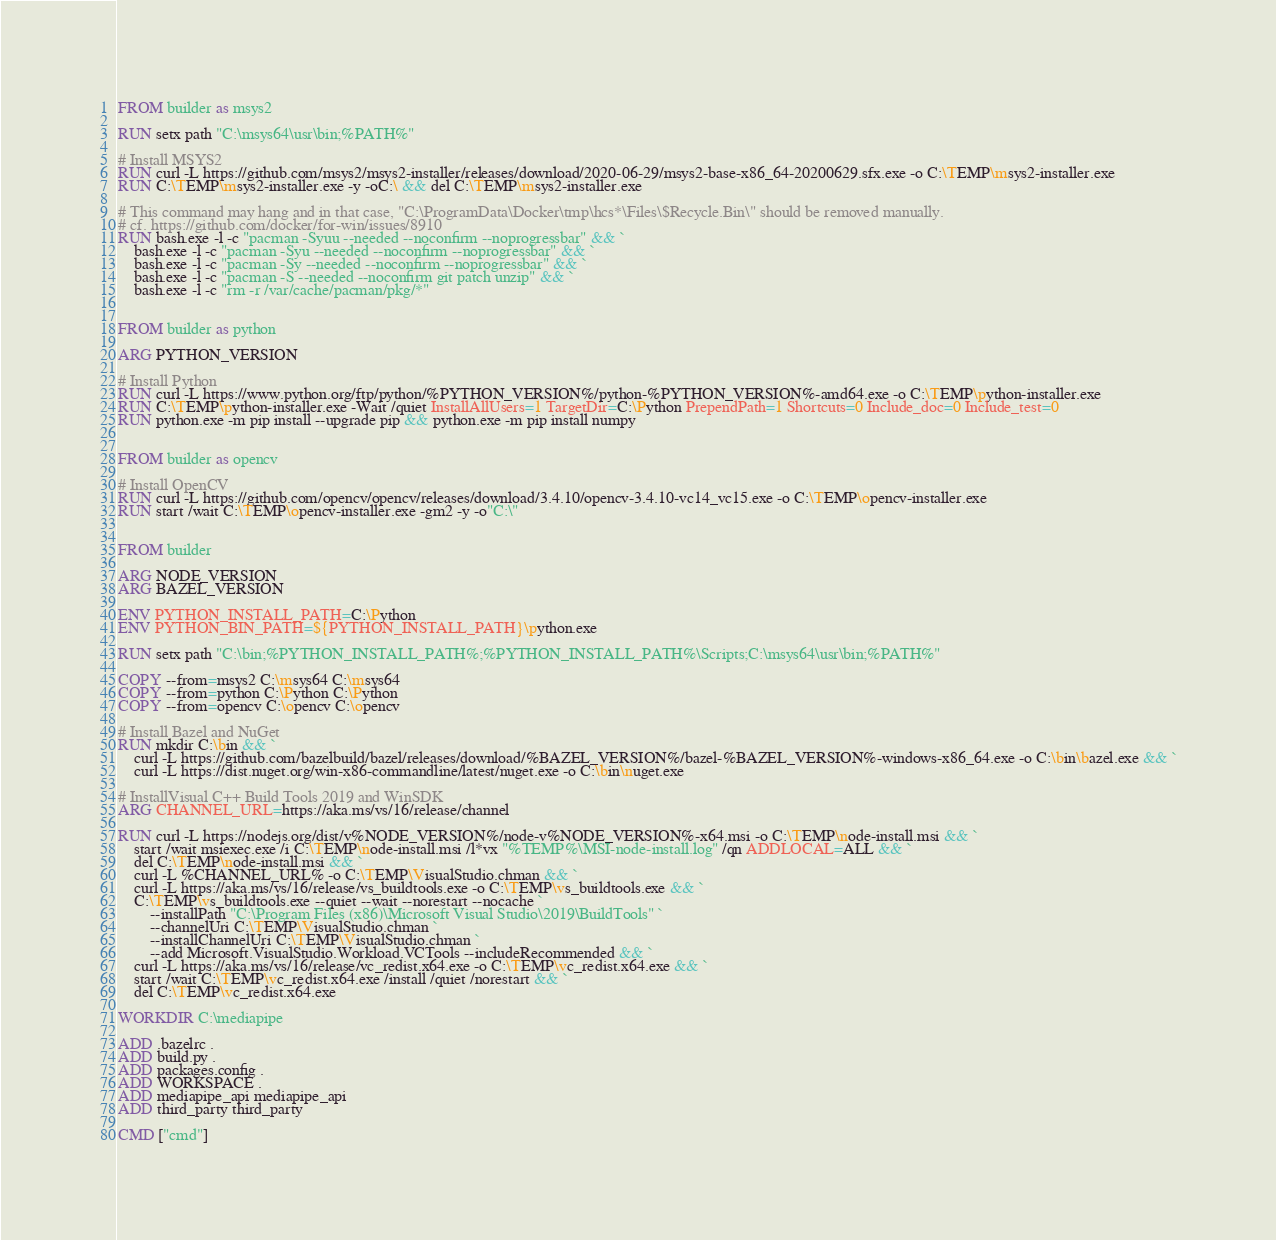Convert code to text. <code><loc_0><loc_0><loc_500><loc_500><_Dockerfile_>

FROM builder as msys2

RUN setx path "C:\msys64\usr\bin;%PATH%"

# Install MSYS2
RUN curl -L https://github.com/msys2/msys2-installer/releases/download/2020-06-29/msys2-base-x86_64-20200629.sfx.exe -o C:\TEMP\msys2-installer.exe
RUN C:\TEMP\msys2-installer.exe -y -oC:\ && del C:\TEMP\msys2-installer.exe

# This command may hang and in that case, "C:\ProgramData\Docker\tmp\hcs*\Files\$Recycle.Bin\" should be removed manually.
# cf. https://github.com/docker/for-win/issues/8910
RUN bash.exe -l -c "pacman -Syuu --needed --noconfirm --noprogressbar" && `
    bash.exe -l -c "pacman -Syu --needed --noconfirm --noprogressbar" && `
    bash.exe -l -c "pacman -Sy --needed --noconfirm --noprogressbar" && `
    bash.exe -l -c "pacman -S --needed --noconfirm git patch unzip" && `
    bash.exe -l -c "rm -r /var/cache/pacman/pkg/*"


FROM builder as python

ARG PYTHON_VERSION

# Install Python
RUN curl -L https://www.python.org/ftp/python/%PYTHON_VERSION%/python-%PYTHON_VERSION%-amd64.exe -o C:\TEMP\python-installer.exe
RUN C:\TEMP\python-installer.exe -Wait /quiet InstallAllUsers=1 TargetDir=C:\Python PrependPath=1 Shortcuts=0 Include_doc=0 Include_test=0
RUN python.exe -m pip install --upgrade pip && python.exe -m pip install numpy


FROM builder as opencv

# Install OpenCV
RUN curl -L https://github.com/opencv/opencv/releases/download/3.4.10/opencv-3.4.10-vc14_vc15.exe -o C:\TEMP\opencv-installer.exe
RUN start /wait C:\TEMP\opencv-installer.exe -gm2 -y -o"C:\"


FROM builder

ARG NODE_VERSION
ARG BAZEL_VERSION

ENV PYTHON_INSTALL_PATH=C:\Python
ENV PYTHON_BIN_PATH=${PYTHON_INSTALL_PATH}\python.exe

RUN setx path "C:\bin;%PYTHON_INSTALL_PATH%;%PYTHON_INSTALL_PATH%\Scripts;C:\msys64\usr\bin;%PATH%"

COPY --from=msys2 C:\msys64 C:\msys64
COPY --from=python C:\Python C:\Python
COPY --from=opencv C:\opencv C:\opencv

# Install Bazel and NuGet
RUN mkdir C:\bin && `
    curl -L https://github.com/bazelbuild/bazel/releases/download/%BAZEL_VERSION%/bazel-%BAZEL_VERSION%-windows-x86_64.exe -o C:\bin\bazel.exe && `
    curl -L https://dist.nuget.org/win-x86-commandline/latest/nuget.exe -o C:\bin\nuget.exe

# InstallVisual C++ Build Tools 2019 and WinSDK
ARG CHANNEL_URL=https://aka.ms/vs/16/release/channel

RUN curl -L https://nodejs.org/dist/v%NODE_VERSION%/node-v%NODE_VERSION%-x64.msi -o C:\TEMP\node-install.msi && `
    start /wait msiexec.exe /i C:\TEMP\node-install.msi /l*vx "%TEMP%\MSI-node-install.log" /qn ADDLOCAL=ALL && `
    del C:\TEMP\node-install.msi && `
    curl -L %CHANNEL_URL% -o C:\TEMP\VisualStudio.chman && `
    curl -L https://aka.ms/vs/16/release/vs_buildtools.exe -o C:\TEMP\vs_buildtools.exe && `
    C:\TEMP\vs_buildtools.exe --quiet --wait --norestart --nocache `
        --installPath "C:\Program Files (x86)\Microsoft Visual Studio\2019\BuildTools" `
        --channelUri C:\TEMP\VisualStudio.chman `
        --installChannelUri C:\TEMP\VisualStudio.chman `
        --add Microsoft.VisualStudio.Workload.VCTools --includeRecommended && `
    curl -L https://aka.ms/vs/16/release/vc_redist.x64.exe -o C:\TEMP\vc_redist.x64.exe && `
    start /wait C:\TEMP\vc_redist.x64.exe /install /quiet /norestart && `
    del C:\TEMP\vc_redist.x64.exe

WORKDIR C:\mediapipe

ADD .bazelrc .
ADD build.py .
ADD packages.config .
ADD WORKSPACE .
ADD mediapipe_api mediapipe_api
ADD third_party third_party

CMD ["cmd"]
</code> 